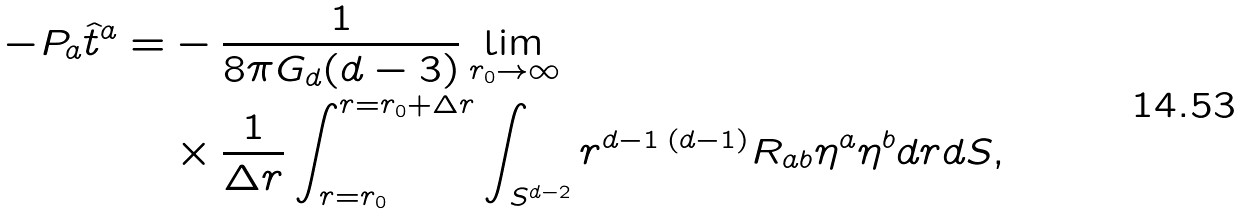<formula> <loc_0><loc_0><loc_500><loc_500>- P _ { a } \hat { t } ^ { a } = & - \frac { 1 } { 8 \pi G _ { d } ( d - 3 ) } \lim _ { r _ { 0 } \rightarrow \infty } \\ & \times \frac { 1 } { \Delta r } \int _ { r = r _ { 0 } } ^ { r = r _ { 0 } + \Delta r } \int _ { S ^ { d - 2 } } r ^ { d - 1 } \, ^ { ( d - 1 ) } R _ { a b } \eta ^ { a } \eta ^ { b } d r d S ,</formula> 